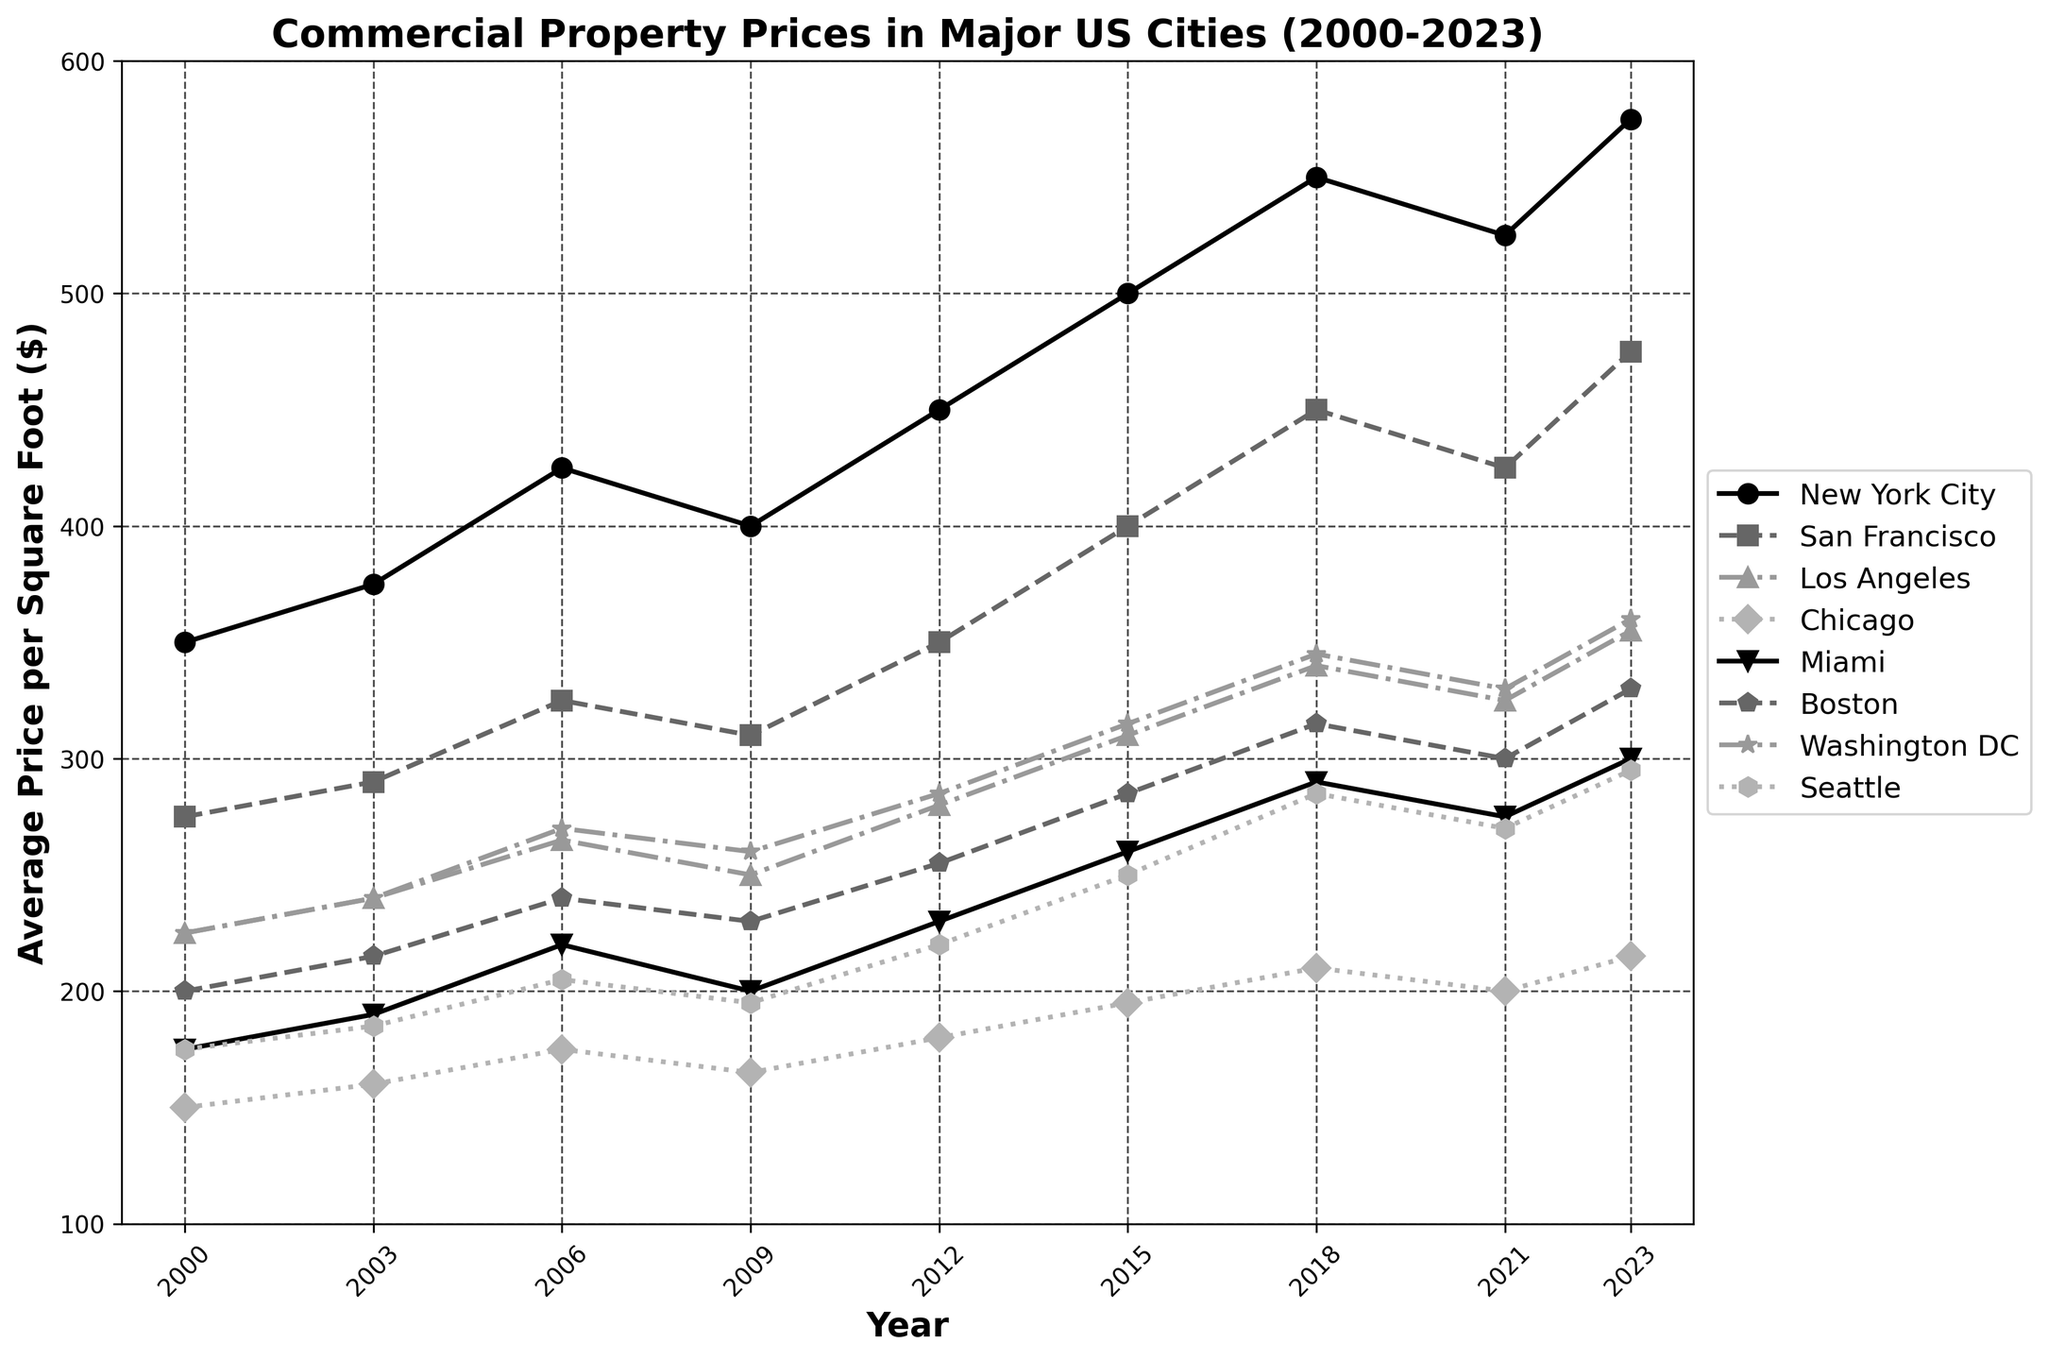What city had the highest average commercial property price in 2023? Look at the 2023 data points; New York City has the highest value.
Answer: New York City Which city experienced the largest increase in average commercial property price from 2012 to 2023? Calculate the difference between 2023 and 2012 for each city: New York City (575-450=125), San Francisco (475-350=125), Los Angeles (355-280=75), Chicago (215-180=35), Miami (300-230=70), Boston (330-255=75), Washington DC (360-285=75), Seattle (295-220=75). New York City and San Francisco both had the largest increase of 125.
Answer: New York City, San Francisco Between which years did Miami see the fastest increase in average commercial property prices? Identify years where the slope (increase) is steepest for Miami: 2012 to 2015 had a change from 230 to 260 (30), 2015 to 2018 had a change from 260 to 290 (30). The increase rate for both intervals is the same.
Answer: 2012 to 2015 and 2015 to 2018 What was the mean average commercial property price in Chicago between 2000 and 2023? Add Chicago's prices for each year then divide by the number of years: (150+160+175+165+180+195+210+200+215)/9 = 1724/9 = 191.56.
Answer: 191.56 Which city had a higher average price in 2000, Boston or Washington DC? Look at the 2000 data points; Boston is 200 and Washington DC is 225.
Answer: Washington DC What was the percentage increase in property prices in San Francisco from 2000 to 2023? Calculate the percentage change: ((475-275)/275)*100 = 72.73%.
Answer: 72.73% Between 2006 and 2023, did Seattle exceed the average price per square foot of Miami, at least once? Compare Seattle and Miami’s prices year by year from 2006 to 2023. Seattle doesn't exceed Miami in any given year in that range.
Answer: No 